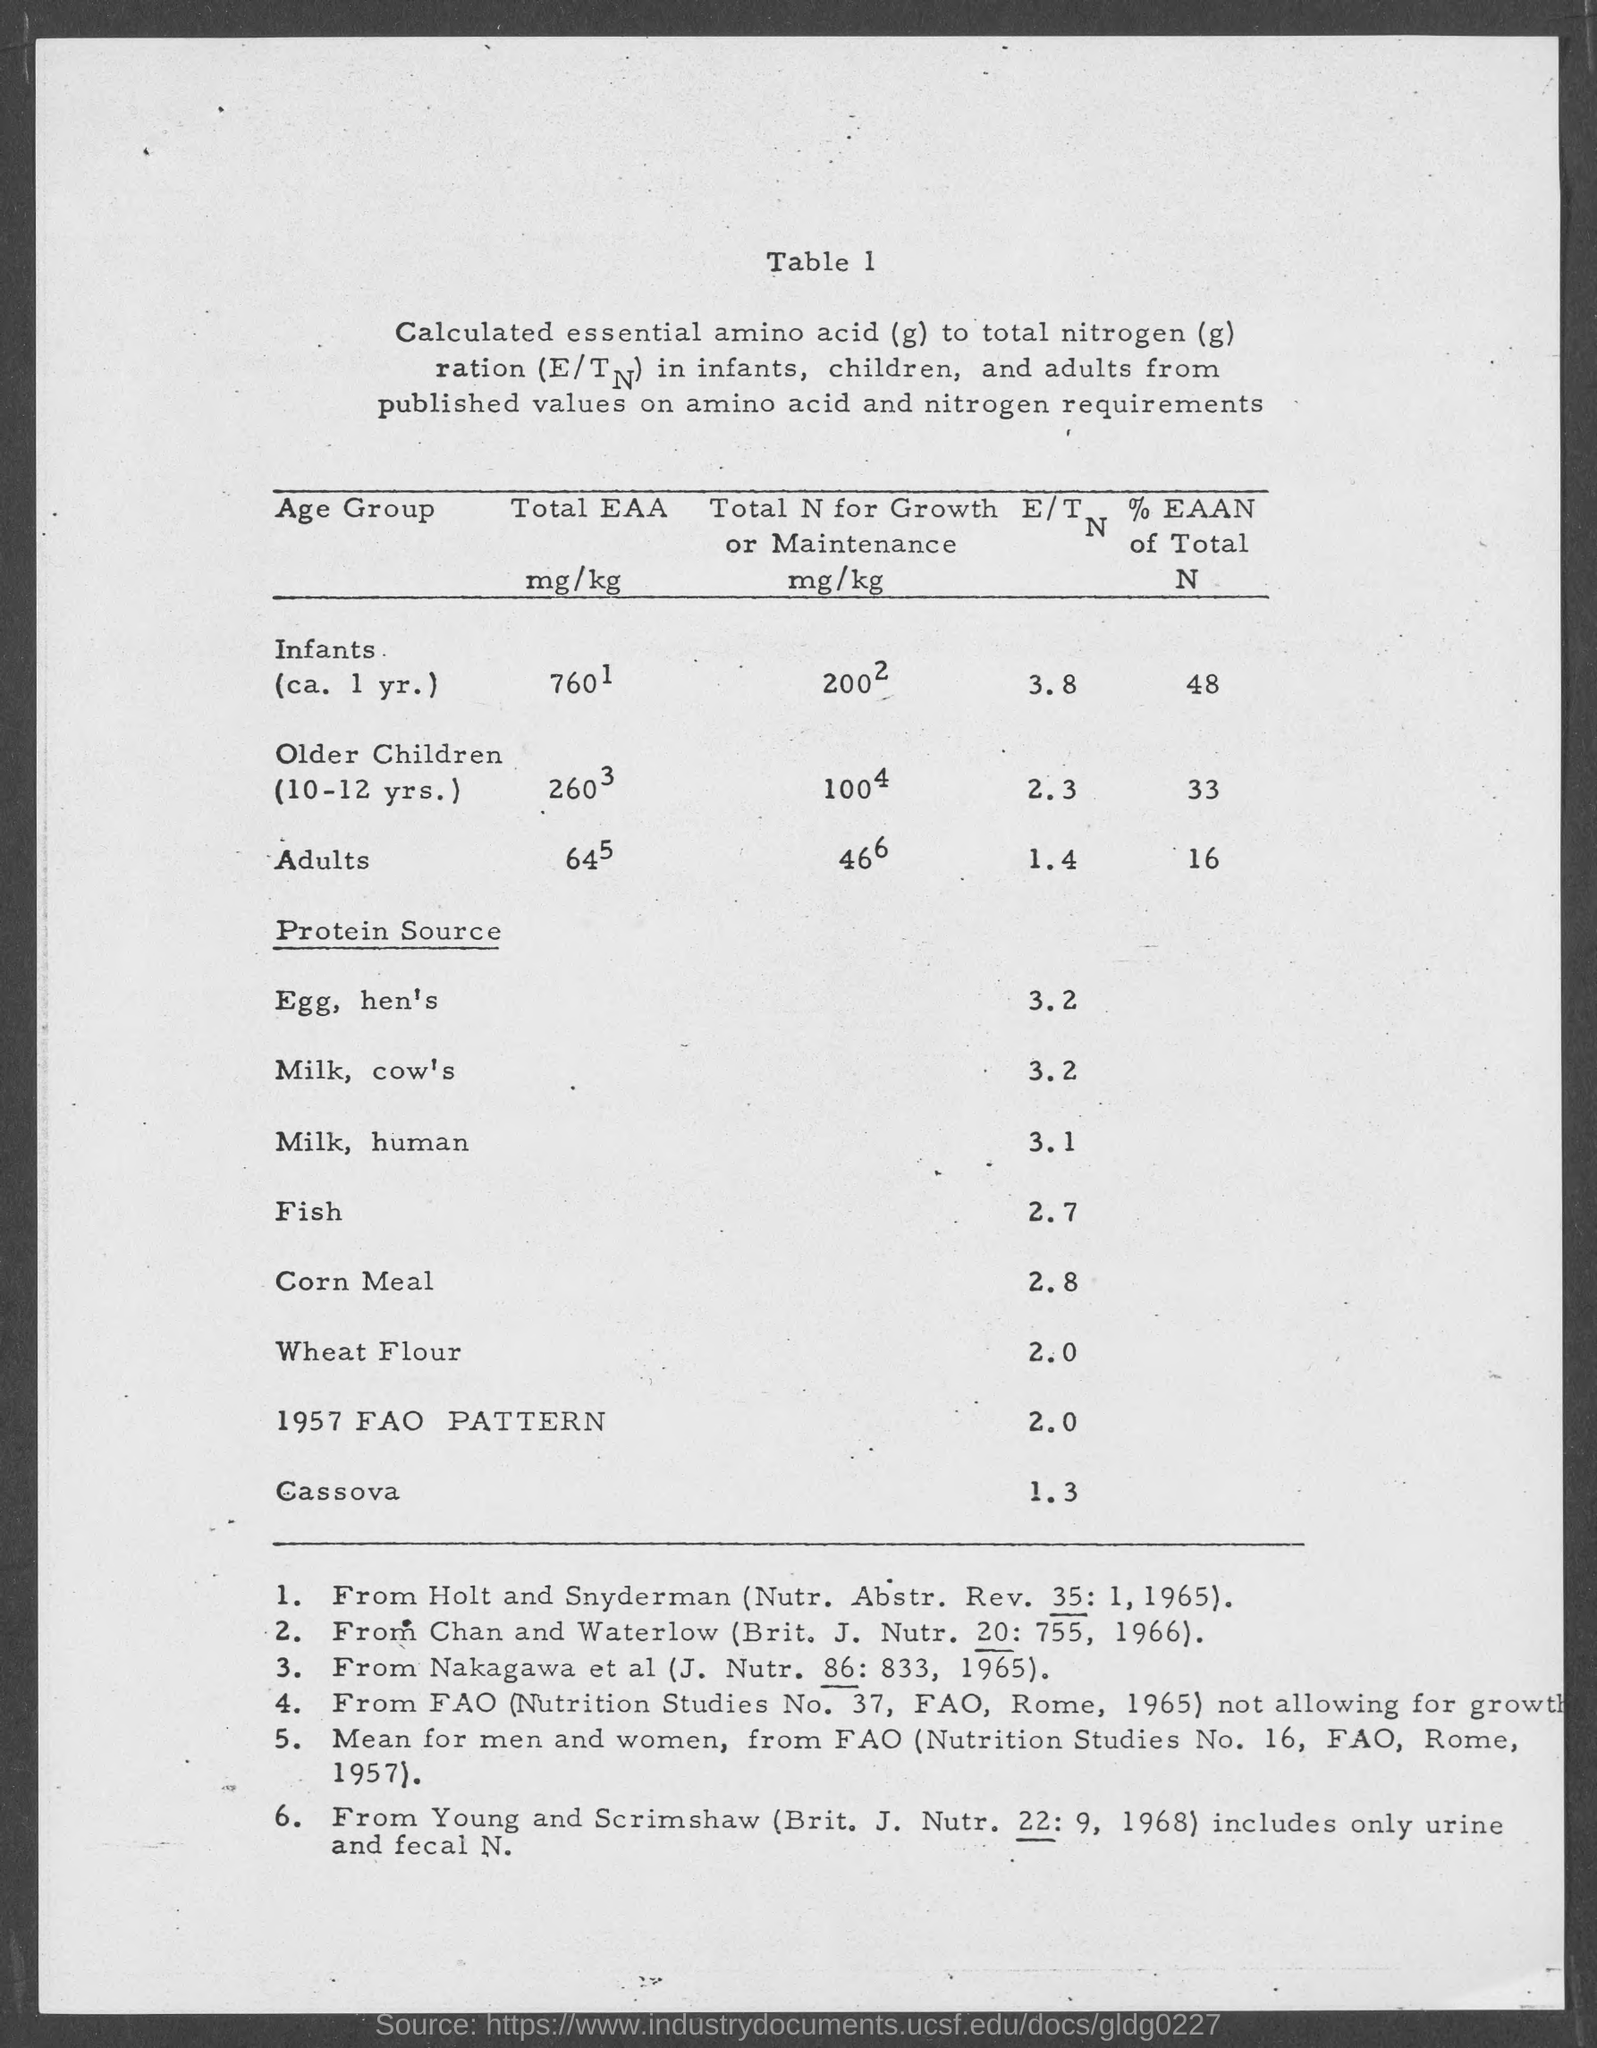Identify some key points in this picture. The E/T ratio for adults is 1.4. The energy-to-protein ratio (E/T) for corn meal is 2.8, which means that 100 grams of corn meal will provide 2.8 grams of energy and 81.2 grams of protein. The E/T for older children is 2.3. The energy to mass ratio (E/T) for milk from a human is 3.1... The E/T ratio for milk from cows is 3.2. 